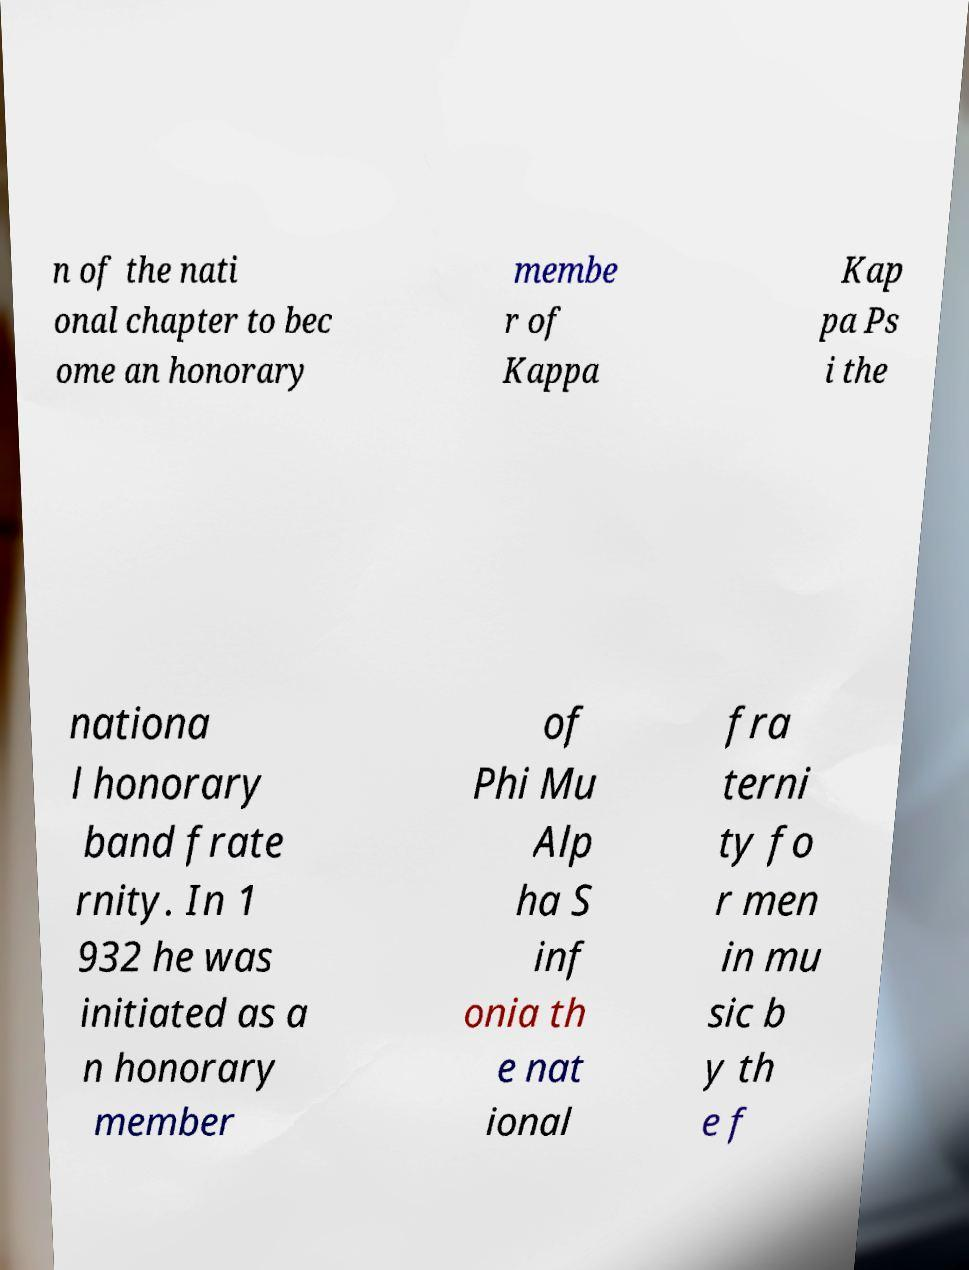Please identify and transcribe the text found in this image. n of the nati onal chapter to bec ome an honorary membe r of Kappa Kap pa Ps i the nationa l honorary band frate rnity. In 1 932 he was initiated as a n honorary member of Phi Mu Alp ha S inf onia th e nat ional fra terni ty fo r men in mu sic b y th e f 